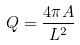<formula> <loc_0><loc_0><loc_500><loc_500>Q = \frac { 4 \pi A } { L ^ { 2 } }</formula> 